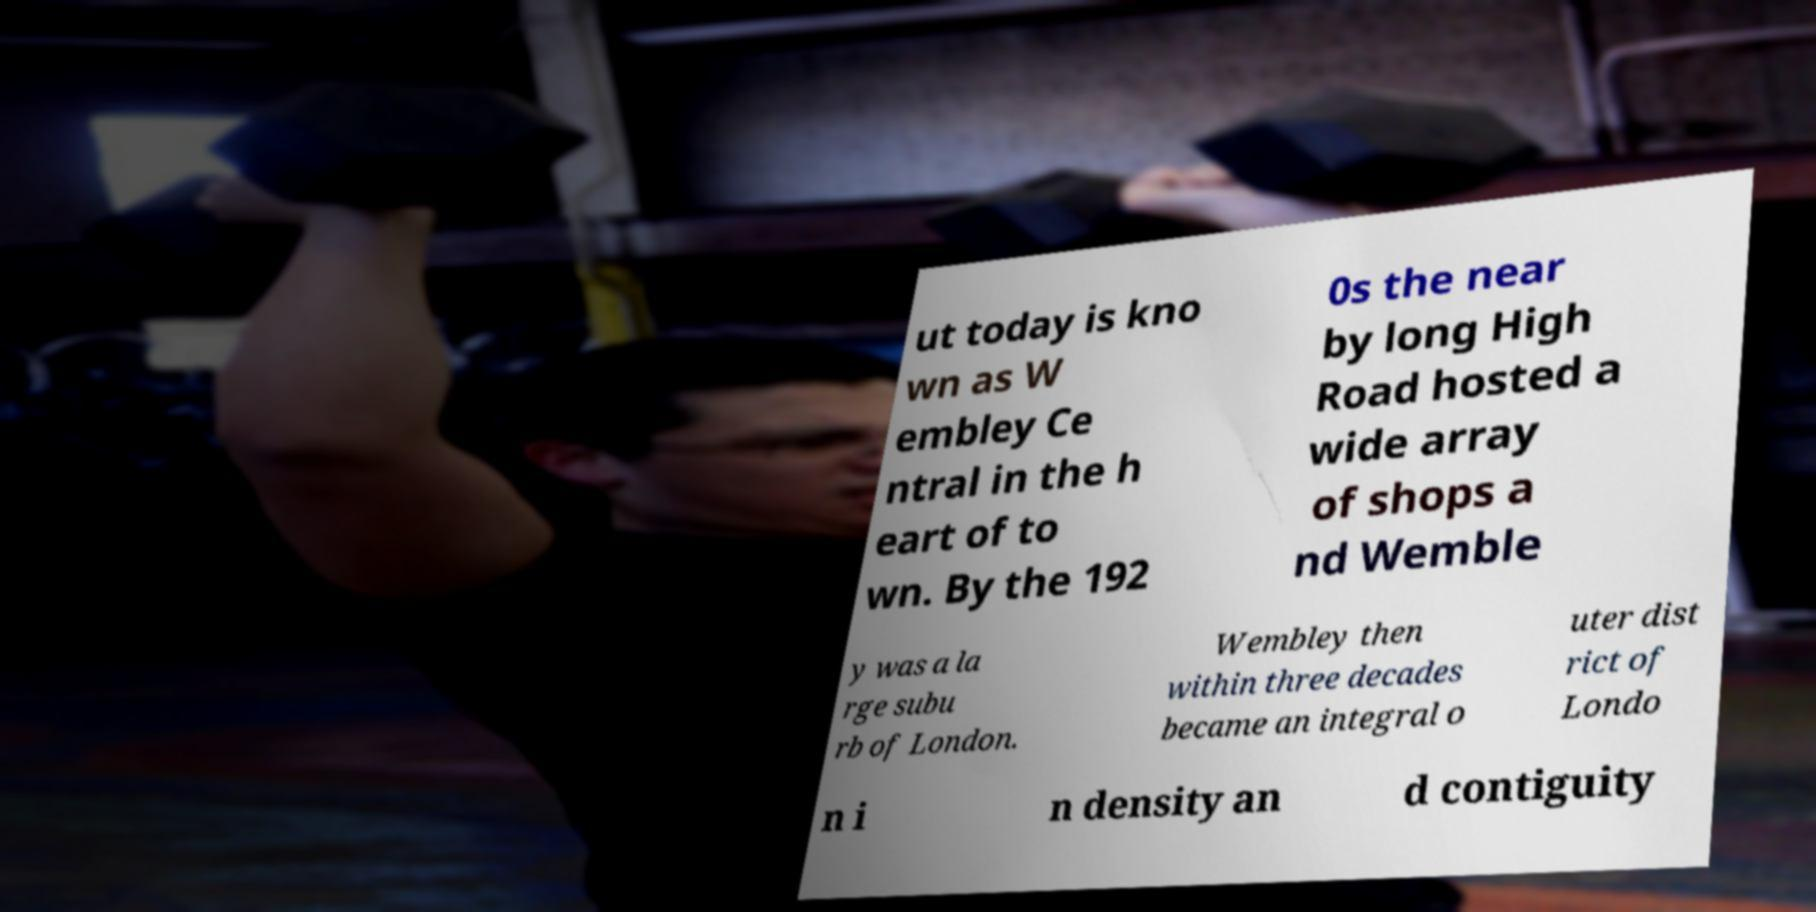Could you assist in decoding the text presented in this image and type it out clearly? ut today is kno wn as W embley Ce ntral in the h eart of to wn. By the 192 0s the near by long High Road hosted a wide array of shops a nd Wemble y was a la rge subu rb of London. Wembley then within three decades became an integral o uter dist rict of Londo n i n density an d contiguity 